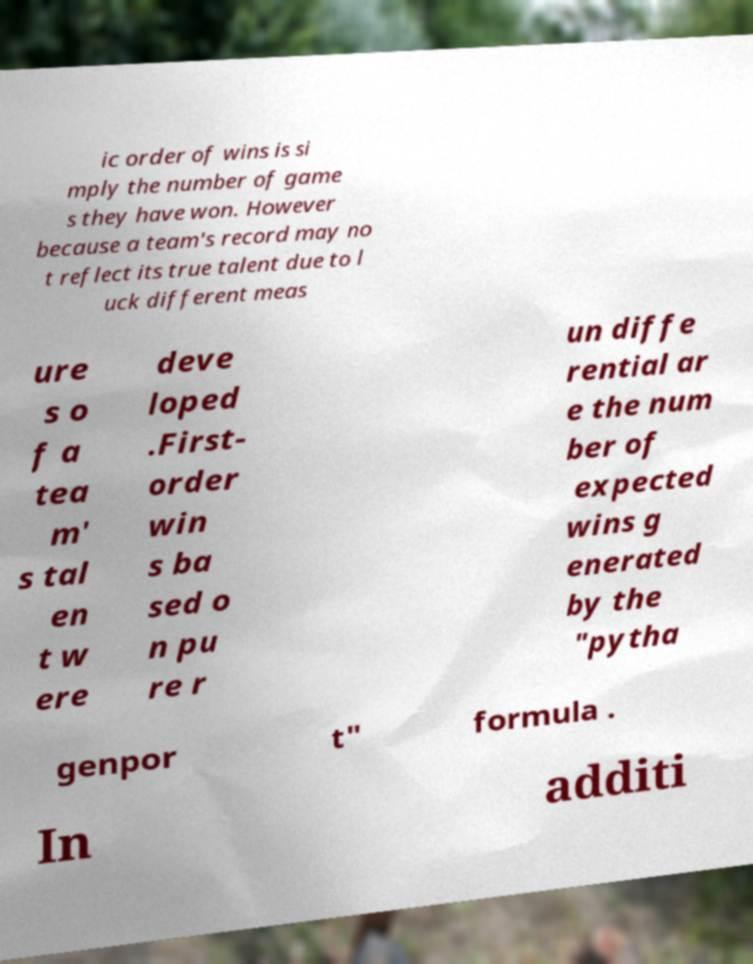Could you assist in decoding the text presented in this image and type it out clearly? ic order of wins is si mply the number of game s they have won. However because a team's record may no t reflect its true talent due to l uck different meas ure s o f a tea m' s tal en t w ere deve loped .First- order win s ba sed o n pu re r un diffe rential ar e the num ber of expected wins g enerated by the "pytha genpor t" formula . In additi 